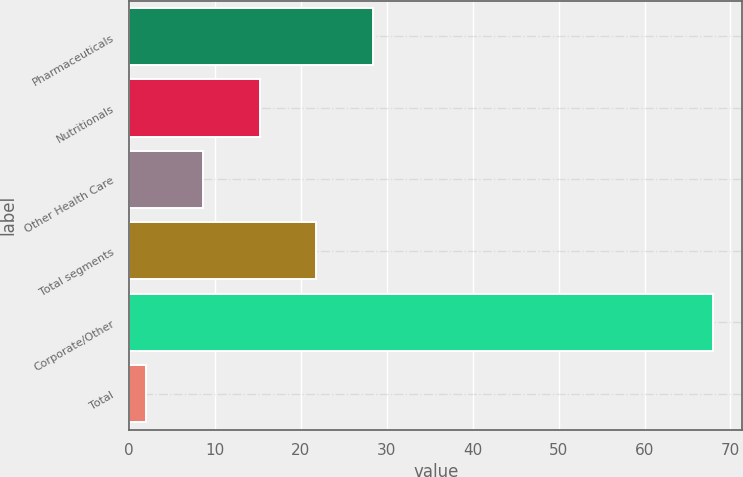Convert chart. <chart><loc_0><loc_0><loc_500><loc_500><bar_chart><fcel>Pharmaceuticals<fcel>Nutritionals<fcel>Other Health Care<fcel>Total segments<fcel>Corporate/Other<fcel>Total<nl><fcel>28.4<fcel>15.2<fcel>8.6<fcel>21.8<fcel>68<fcel>2<nl></chart> 